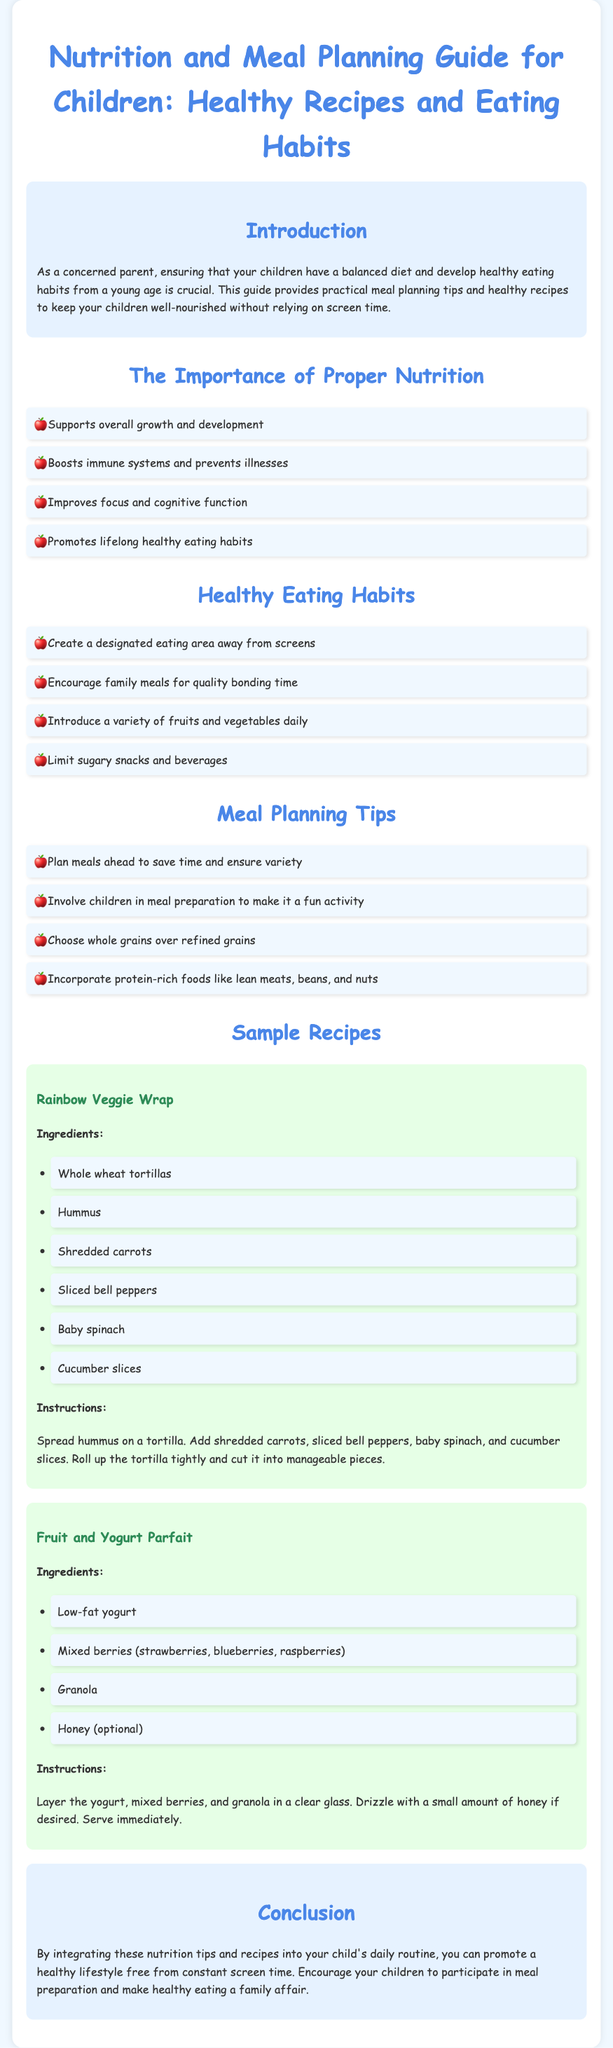What is the title of the document? The title is explicitly stated at the top of the document.
Answer: Nutrition and Meal Planning Guide for Children: Healthy Recipes and Eating Habits What is one benefit of proper nutrition mentioned? The document lists benefits in a bulleted format under the section "The Importance of Proper Nutrition."
Answer: Boosts immune systems and prevents illnesses What is a healthy eating habit to adopt? The document provides a list of healthy eating habits that can be followed.
Answer: Create a designated eating area away from screens How many sample recipes are provided? The document gives a specific number of recipes under the section "Sample Recipes."
Answer: Two What ingredient is used in the Rainbow Veggie Wrap? The document lists ingredients in the Recipe section for each recipe.
Answer: Hummus What type of yogurt is suggested in the Fruit and Yogurt Parfait? The recipe specifies the type of yogurt to be used.
Answer: Low-fat yogurt What is a major focus of the introduction? The introduction outlines the primary concern addressed in the guide.
Answer: Balanced diet and healthy eating habits Why is it important for children to participate in meal preparation? The document highlights the benefits of involving children in meal prep.
Answer: Make it a fun activity 